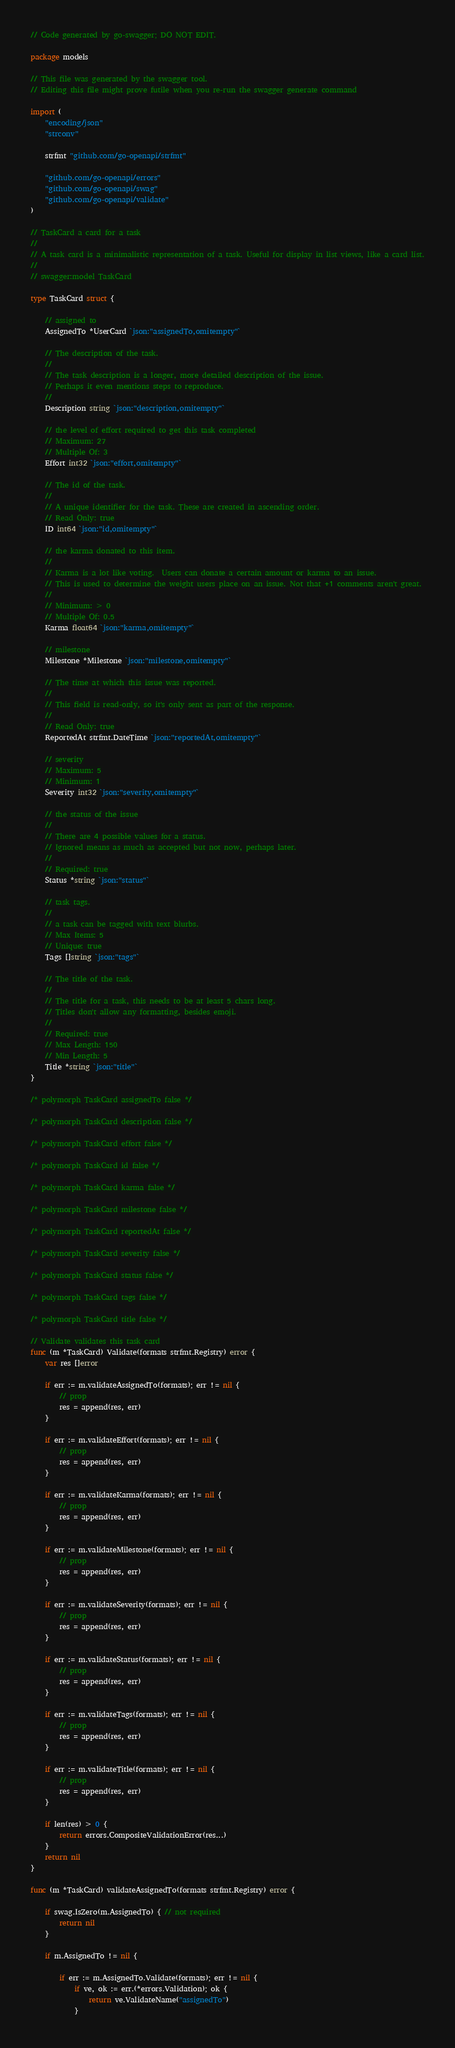<code> <loc_0><loc_0><loc_500><loc_500><_Go_>// Code generated by go-swagger; DO NOT EDIT.

package models

// This file was generated by the swagger tool.
// Editing this file might prove futile when you re-run the swagger generate command

import (
	"encoding/json"
	"strconv"

	strfmt "github.com/go-openapi/strfmt"

	"github.com/go-openapi/errors"
	"github.com/go-openapi/swag"
	"github.com/go-openapi/validate"
)

// TaskCard a card for a task
//
// A task card is a minimalistic representation of a task. Useful for display in list views, like a card list.
//
// swagger:model TaskCard

type TaskCard struct {

	// assigned to
	AssignedTo *UserCard `json:"assignedTo,omitempty"`

	// The description of the task.
	//
	// The task description is a longer, more detailed description of the issue.
	// Perhaps it even mentions steps to reproduce.
	//
	Description string `json:"description,omitempty"`

	// the level of effort required to get this task completed
	// Maximum: 27
	// Multiple Of: 3
	Effort int32 `json:"effort,omitempty"`

	// The id of the task.
	//
	// A unique identifier for the task. These are created in ascending order.
	// Read Only: true
	ID int64 `json:"id,omitempty"`

	// the karma donated to this item.
	//
	// Karma is a lot like voting.  Users can donate a certain amount or karma to an issue.
	// This is used to determine the weight users place on an issue. Not that +1 comments aren't great.
	//
	// Minimum: > 0
	// Multiple Of: 0.5
	Karma float64 `json:"karma,omitempty"`

	// milestone
	Milestone *Milestone `json:"milestone,omitempty"`

	// The time at which this issue was reported.
	//
	// This field is read-only, so it's only sent as part of the response.
	//
	// Read Only: true
	ReportedAt strfmt.DateTime `json:"reportedAt,omitempty"`

	// severity
	// Maximum: 5
	// Minimum: 1
	Severity int32 `json:"severity,omitempty"`

	// the status of the issue
	//
	// There are 4 possible values for a status.
	// Ignored means as much as accepted but not now, perhaps later.
	//
	// Required: true
	Status *string `json:"status"`

	// task tags.
	//
	// a task can be tagged with text blurbs.
	// Max Items: 5
	// Unique: true
	Tags []string `json:"tags"`

	// The title of the task.
	//
	// The title for a task, this needs to be at least 5 chars long.
	// Titles don't allow any formatting, besides emoji.
	//
	// Required: true
	// Max Length: 150
	// Min Length: 5
	Title *string `json:"title"`
}

/* polymorph TaskCard assignedTo false */

/* polymorph TaskCard description false */

/* polymorph TaskCard effort false */

/* polymorph TaskCard id false */

/* polymorph TaskCard karma false */

/* polymorph TaskCard milestone false */

/* polymorph TaskCard reportedAt false */

/* polymorph TaskCard severity false */

/* polymorph TaskCard status false */

/* polymorph TaskCard tags false */

/* polymorph TaskCard title false */

// Validate validates this task card
func (m *TaskCard) Validate(formats strfmt.Registry) error {
	var res []error

	if err := m.validateAssignedTo(formats); err != nil {
		// prop
		res = append(res, err)
	}

	if err := m.validateEffort(formats); err != nil {
		// prop
		res = append(res, err)
	}

	if err := m.validateKarma(formats); err != nil {
		// prop
		res = append(res, err)
	}

	if err := m.validateMilestone(formats); err != nil {
		// prop
		res = append(res, err)
	}

	if err := m.validateSeverity(formats); err != nil {
		// prop
		res = append(res, err)
	}

	if err := m.validateStatus(formats); err != nil {
		// prop
		res = append(res, err)
	}

	if err := m.validateTags(formats); err != nil {
		// prop
		res = append(res, err)
	}

	if err := m.validateTitle(formats); err != nil {
		// prop
		res = append(res, err)
	}

	if len(res) > 0 {
		return errors.CompositeValidationError(res...)
	}
	return nil
}

func (m *TaskCard) validateAssignedTo(formats strfmt.Registry) error {

	if swag.IsZero(m.AssignedTo) { // not required
		return nil
	}

	if m.AssignedTo != nil {

		if err := m.AssignedTo.Validate(formats); err != nil {
			if ve, ok := err.(*errors.Validation); ok {
				return ve.ValidateName("assignedTo")
			}</code> 